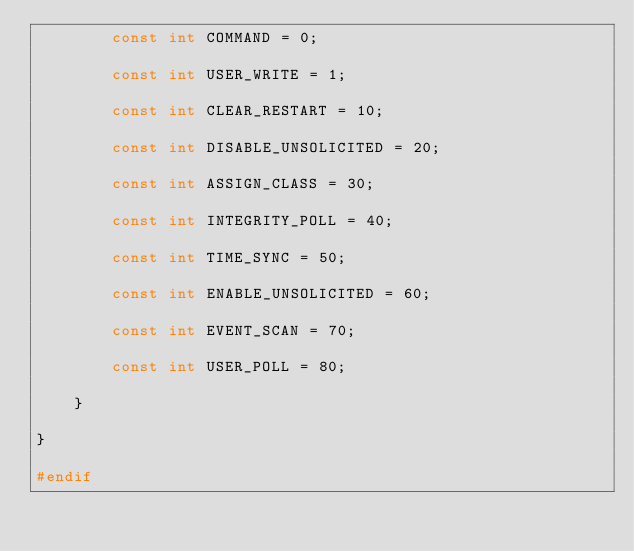<code> <loc_0><loc_0><loc_500><loc_500><_C_>		const int COMMAND = 0;

		const int USER_WRITE = 1;
		
		const int CLEAR_RESTART = 10;
		
		const int DISABLE_UNSOLICITED = 20;

		const int ASSIGN_CLASS = 30;
				
		const int INTEGRITY_POLL = 40;

		const int TIME_SYNC = 50;		

		const int ENABLE_UNSOLICITED = 60;

		const int EVENT_SCAN = 70;

		const int USER_POLL = 80;

	}

}

#endif
</code> 